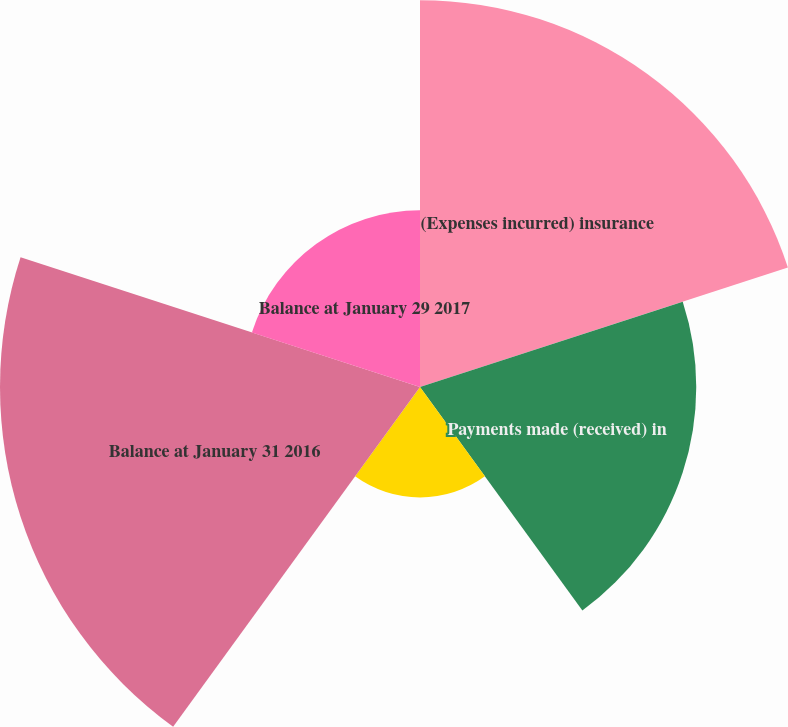Convert chart. <chart><loc_0><loc_0><loc_500><loc_500><pie_chart><fcel>(Expenses incurred) insurance<fcel>Payments made (received) in<fcel>Balance at February 1 2015<fcel>Balance at January 31 2016<fcel>Balance at January 29 2017<nl><fcel>28.23%<fcel>20.16%<fcel>8.06%<fcel>30.65%<fcel>12.9%<nl></chart> 